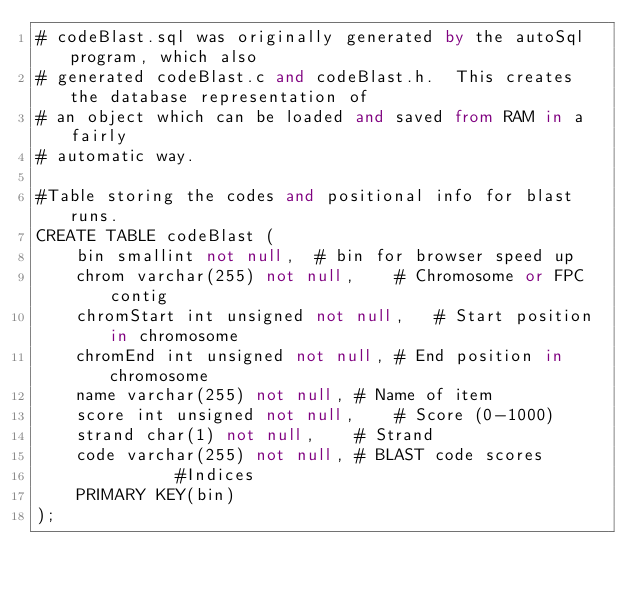<code> <loc_0><loc_0><loc_500><loc_500><_SQL_># codeBlast.sql was originally generated by the autoSql program, which also 
# generated codeBlast.c and codeBlast.h.  This creates the database representation of
# an object which can be loaded and saved from RAM in a fairly 
# automatic way.

#Table storing the codes and positional info for blast runs.
CREATE TABLE codeBlast (
    bin smallint not null,	# bin for browser speed up
    chrom varchar(255) not null,	# Chromosome or FPC contig
    chromStart int unsigned not null,	# Start position in chromosome
    chromEnd int unsigned not null,	# End position in chromosome
    name varchar(255) not null,	# Name of item
    score int unsigned not null,	# Score (0-1000)
    strand char(1) not null,	# Strand
    code varchar(255) not null,	# BLAST code scores
              #Indices
    PRIMARY KEY(bin)
);
</code> 